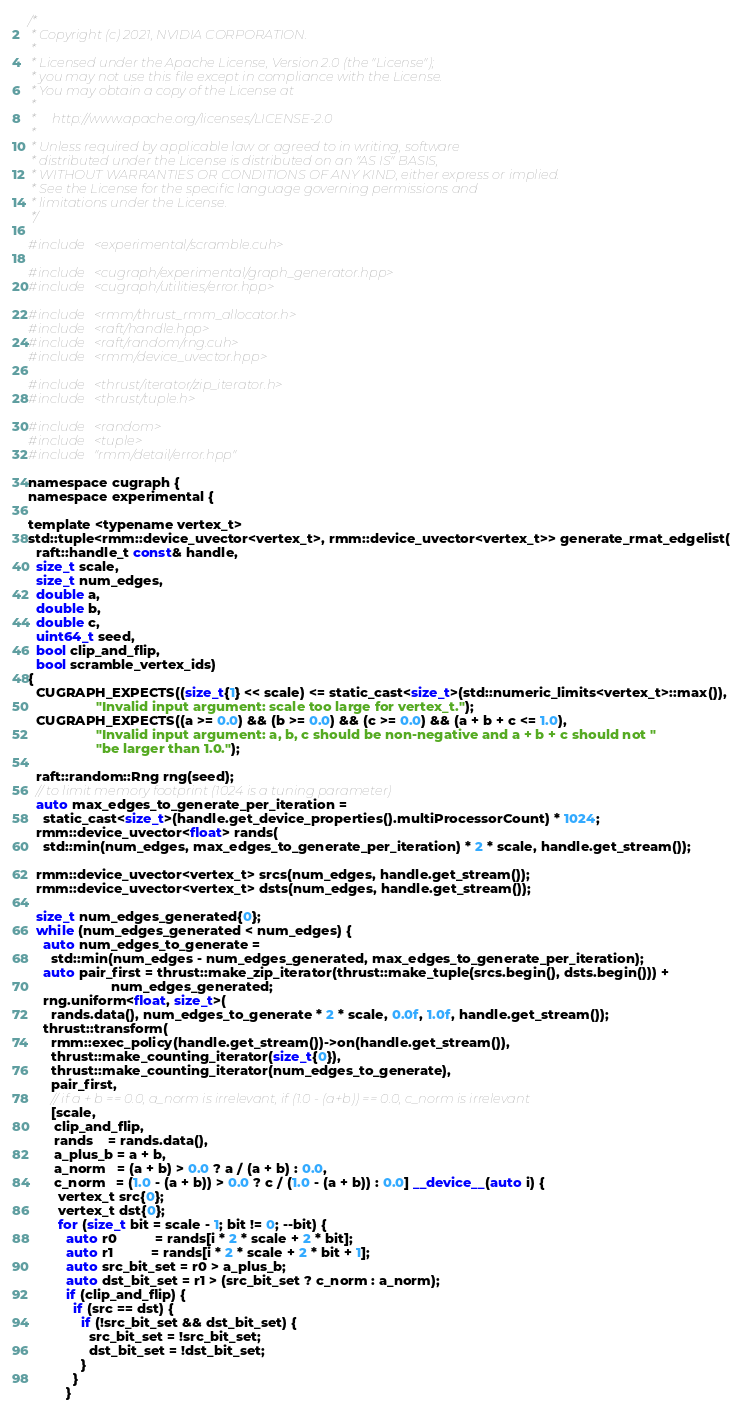Convert code to text. <code><loc_0><loc_0><loc_500><loc_500><_Cuda_>/*
 * Copyright (c) 2021, NVIDIA CORPORATION.
 *
 * Licensed under the Apache License, Version 2.0 (the "License");
 * you may not use this file except in compliance with the License.
 * You may obtain a copy of the License at
 *
 *     http://www.apache.org/licenses/LICENSE-2.0
 *
 * Unless required by applicable law or agreed to in writing, software
 * distributed under the License is distributed on an "AS IS" BASIS,
 * WITHOUT WARRANTIES OR CONDITIONS OF ANY KIND, either express or implied.
 * See the License for the specific language governing permissions and
 * limitations under the License.
 */

#include <experimental/scramble.cuh>

#include <cugraph/experimental/graph_generator.hpp>
#include <cugraph/utilities/error.hpp>

#include <rmm/thrust_rmm_allocator.h>
#include <raft/handle.hpp>
#include <raft/random/rng.cuh>
#include <rmm/device_uvector.hpp>

#include <thrust/iterator/zip_iterator.h>
#include <thrust/tuple.h>

#include <random>
#include <tuple>
#include "rmm/detail/error.hpp"

namespace cugraph {
namespace experimental {

template <typename vertex_t>
std::tuple<rmm::device_uvector<vertex_t>, rmm::device_uvector<vertex_t>> generate_rmat_edgelist(
  raft::handle_t const& handle,
  size_t scale,
  size_t num_edges,
  double a,
  double b,
  double c,
  uint64_t seed,
  bool clip_and_flip,
  bool scramble_vertex_ids)
{
  CUGRAPH_EXPECTS((size_t{1} << scale) <= static_cast<size_t>(std::numeric_limits<vertex_t>::max()),
                  "Invalid input argument: scale too large for vertex_t.");
  CUGRAPH_EXPECTS((a >= 0.0) && (b >= 0.0) && (c >= 0.0) && (a + b + c <= 1.0),
                  "Invalid input argument: a, b, c should be non-negative and a + b + c should not "
                  "be larger than 1.0.");

  raft::random::Rng rng(seed);
  // to limit memory footprint (1024 is a tuning parameter)
  auto max_edges_to_generate_per_iteration =
    static_cast<size_t>(handle.get_device_properties().multiProcessorCount) * 1024;
  rmm::device_uvector<float> rands(
    std::min(num_edges, max_edges_to_generate_per_iteration) * 2 * scale, handle.get_stream());

  rmm::device_uvector<vertex_t> srcs(num_edges, handle.get_stream());
  rmm::device_uvector<vertex_t> dsts(num_edges, handle.get_stream());

  size_t num_edges_generated{0};
  while (num_edges_generated < num_edges) {
    auto num_edges_to_generate =
      std::min(num_edges - num_edges_generated, max_edges_to_generate_per_iteration);
    auto pair_first = thrust::make_zip_iterator(thrust::make_tuple(srcs.begin(), dsts.begin())) +
                      num_edges_generated;
    rng.uniform<float, size_t>(
      rands.data(), num_edges_to_generate * 2 * scale, 0.0f, 1.0f, handle.get_stream());
    thrust::transform(
      rmm::exec_policy(handle.get_stream())->on(handle.get_stream()),
      thrust::make_counting_iterator(size_t{0}),
      thrust::make_counting_iterator(num_edges_to_generate),
      pair_first,
      // if a + b == 0.0, a_norm is irrelevant, if (1.0 - (a+b)) == 0.0, c_norm is irrelevant
      [scale,
       clip_and_flip,
       rands    = rands.data(),
       a_plus_b = a + b,
       a_norm   = (a + b) > 0.0 ? a / (a + b) : 0.0,
       c_norm   = (1.0 - (a + b)) > 0.0 ? c / (1.0 - (a + b)) : 0.0] __device__(auto i) {
        vertex_t src{0};
        vertex_t dst{0};
        for (size_t bit = scale - 1; bit != 0; --bit) {
          auto r0          = rands[i * 2 * scale + 2 * bit];
          auto r1          = rands[i * 2 * scale + 2 * bit + 1];
          auto src_bit_set = r0 > a_plus_b;
          auto dst_bit_set = r1 > (src_bit_set ? c_norm : a_norm);
          if (clip_and_flip) {
            if (src == dst) {
              if (!src_bit_set && dst_bit_set) {
                src_bit_set = !src_bit_set;
                dst_bit_set = !dst_bit_set;
              }
            }
          }</code> 